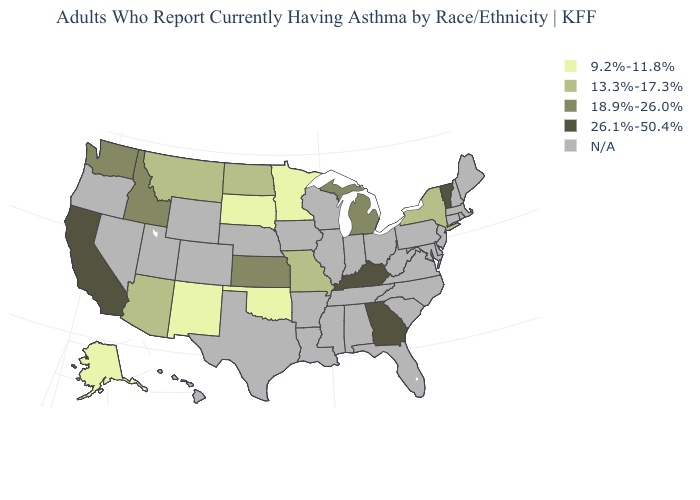What is the value of Arizona?
Write a very short answer. 13.3%-17.3%. What is the value of Kentucky?
Answer briefly. 26.1%-50.4%. What is the lowest value in the MidWest?
Concise answer only. 9.2%-11.8%. Does Missouri have the lowest value in the MidWest?
Give a very brief answer. No. What is the value of Idaho?
Write a very short answer. 18.9%-26.0%. What is the value of Utah?
Give a very brief answer. N/A. Which states hav the highest value in the MidWest?
Concise answer only. Kansas, Michigan. What is the value of Nebraska?
Concise answer only. N/A. Name the states that have a value in the range 13.3%-17.3%?
Be succinct. Arizona, Missouri, Montana, New York, North Dakota. Name the states that have a value in the range 18.9%-26.0%?
Concise answer only. Idaho, Kansas, Michigan, Washington. Which states have the lowest value in the USA?
Concise answer only. Alaska, Minnesota, New Mexico, Oklahoma, South Dakota. What is the value of Mississippi?
Give a very brief answer. N/A. 